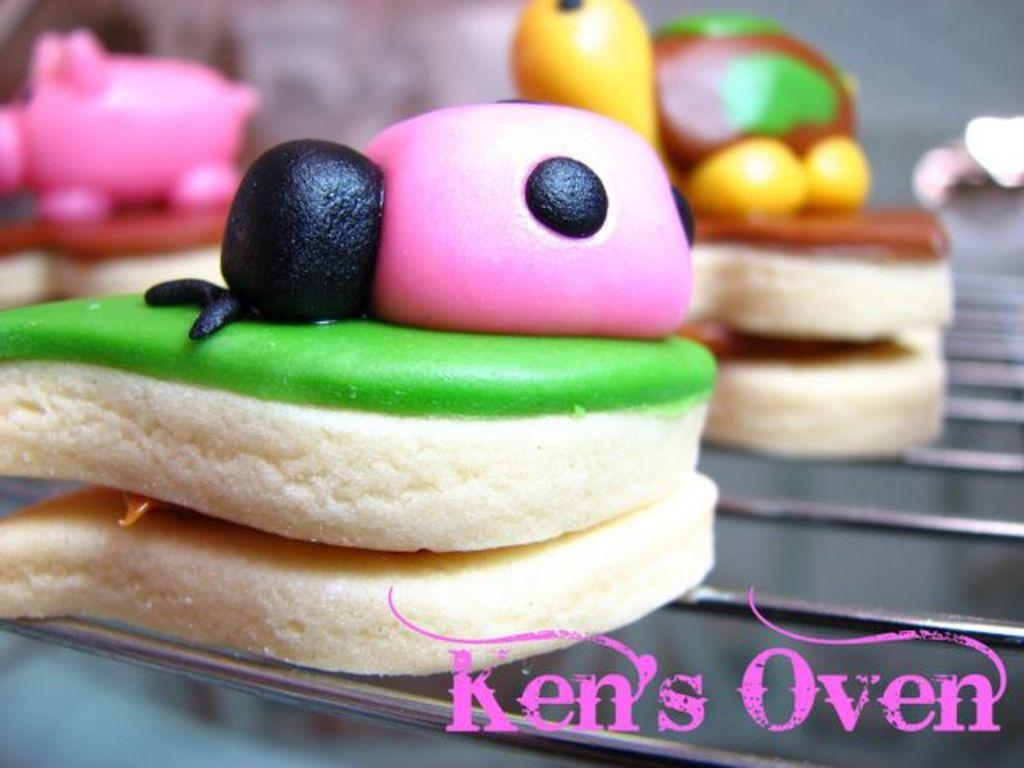What type of food can be seen on the oven in the image? There are desserts on the oven in the image. Is there any text present in the image? Yes, there is some text at the bottom of the image. How many toys can be seen playing with the ladybug in the image? There are no toys or ladybugs present in the image. 